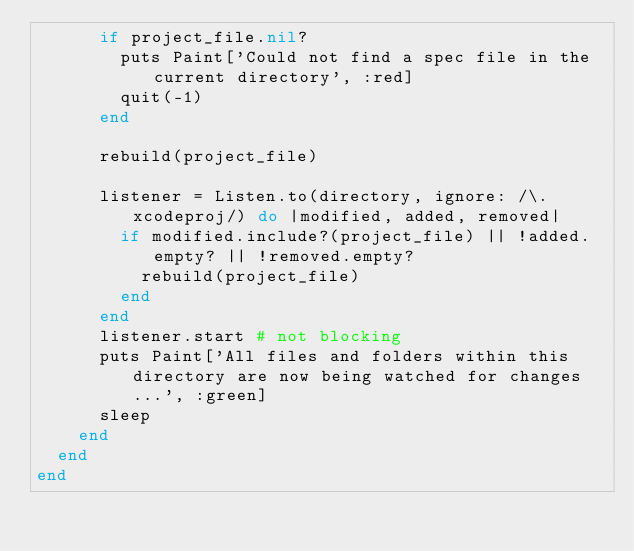<code> <loc_0><loc_0><loc_500><loc_500><_Ruby_>			if project_file.nil?
				puts Paint['Could not find a spec file in the current directory', :red]
				quit(-1)
			end

			rebuild(project_file)

			listener = Listen.to(directory, ignore: /\.xcodeproj/) do |modified, added, removed|
				if modified.include?(project_file) || !added.empty? || !removed.empty?
					rebuild(project_file)
				end
			end
			listener.start # not blocking
			puts Paint['All files and folders within this directory are now being watched for changes...', :green]
			sleep
		end
	end
end</code> 